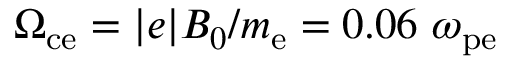Convert formula to latex. <formula><loc_0><loc_0><loc_500><loc_500>\Omega _ { c e } = | e | B _ { 0 } / m _ { e } = 0 . 0 6 \omega _ { p e }</formula> 